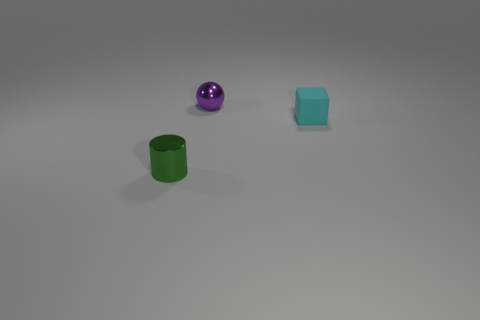The small object that is made of the same material as the ball is what color? green 